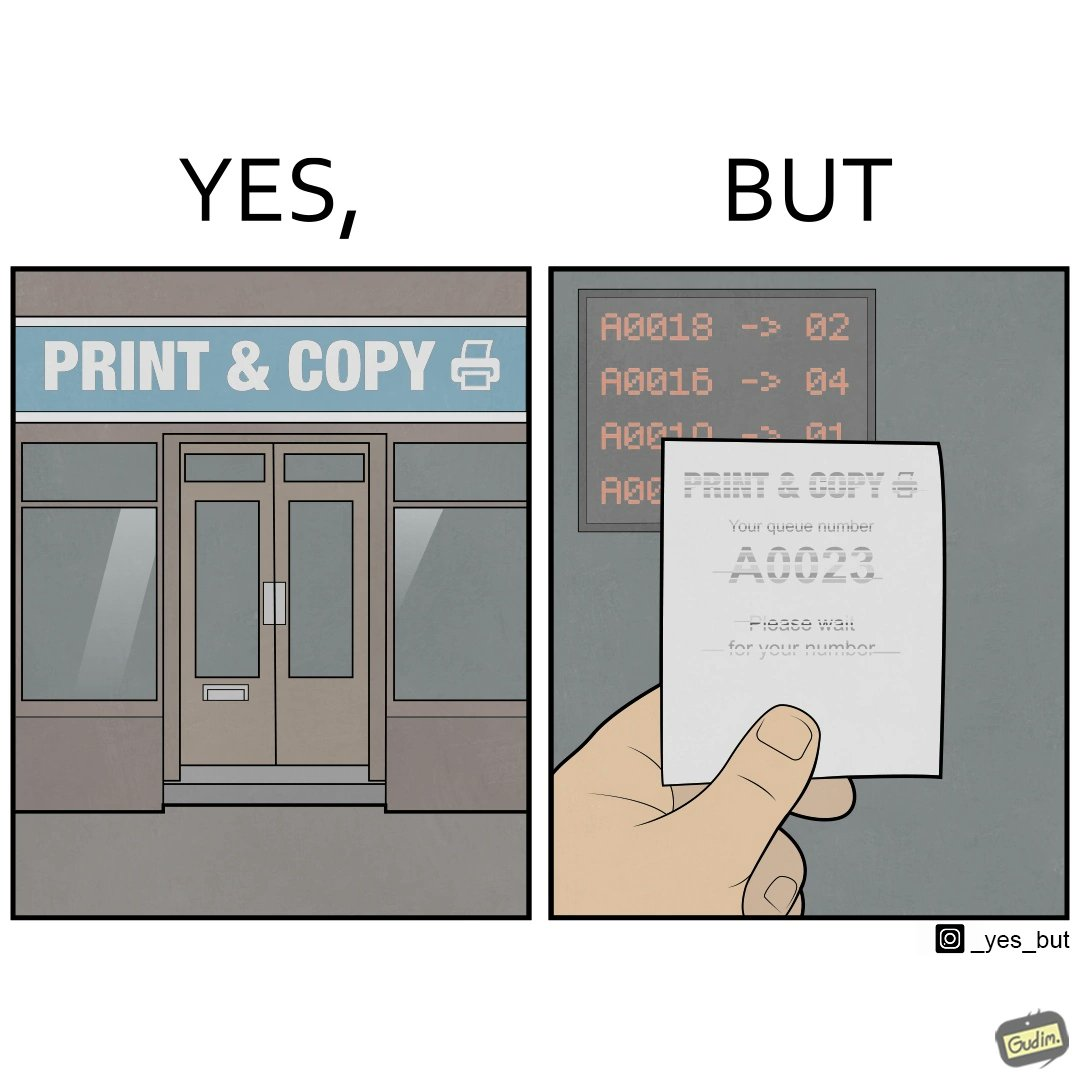Why is this image considered satirical? The image is ironic, as the waiting slip in a "Print & Copy" Centre is printed with insufficient printing ink. 